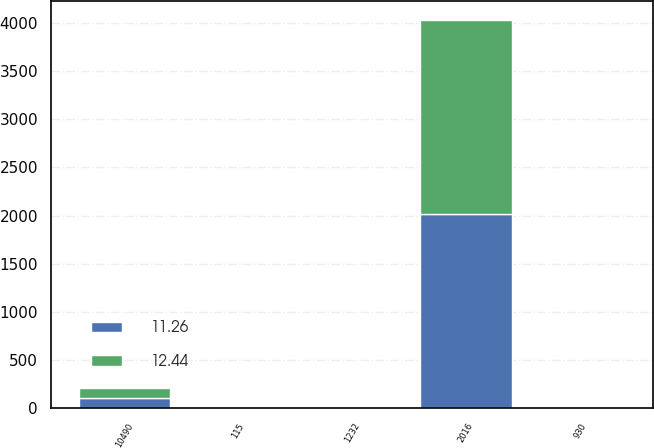<chart> <loc_0><loc_0><loc_500><loc_500><stacked_bar_chart><ecel><fcel>2016<fcel>10490<fcel>115<fcel>930<fcel>1232<nl><fcel>11.26<fcel>2015<fcel>105.24<fcel>0.59<fcel>4.75<fcel>12.44<nl><fcel>12.44<fcel>2014<fcel>104.46<fcel>0.64<fcel>5.69<fcel>11.26<nl></chart> 